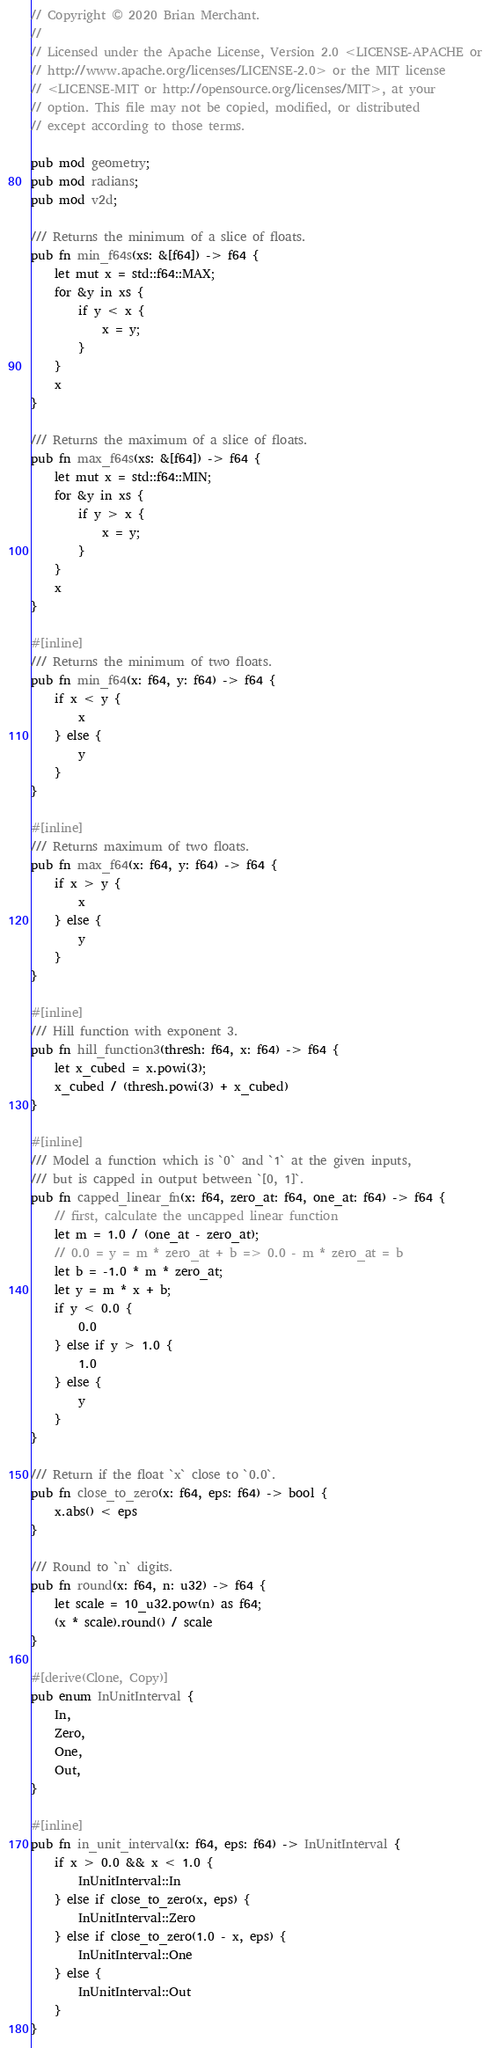Convert code to text. <code><loc_0><loc_0><loc_500><loc_500><_Rust_>// Copyright © 2020 Brian Merchant.
//
// Licensed under the Apache License, Version 2.0 <LICENSE-APACHE or
// http://www.apache.org/licenses/LICENSE-2.0> or the MIT license
// <LICENSE-MIT or http://opensource.org/licenses/MIT>, at your
// option. This file may not be copied, modified, or distributed
// except according to those terms.

pub mod geometry;
pub mod radians;
pub mod v2d;

/// Returns the minimum of a slice of floats.
pub fn min_f64s(xs: &[f64]) -> f64 {
    let mut x = std::f64::MAX;
    for &y in xs {
        if y < x {
            x = y;
        }
    }
    x
}

/// Returns the maximum of a slice of floats.
pub fn max_f64s(xs: &[f64]) -> f64 {
    let mut x = std::f64::MIN;
    for &y in xs {
        if y > x {
            x = y;
        }
    }
    x
}

#[inline]
/// Returns the minimum of two floats.
pub fn min_f64(x: f64, y: f64) -> f64 {
    if x < y {
        x
    } else {
        y
    }
}

#[inline]
/// Returns maximum of two floats.
pub fn max_f64(x: f64, y: f64) -> f64 {
    if x > y {
        x
    } else {
        y
    }
}

#[inline]
/// Hill function with exponent 3.
pub fn hill_function3(thresh: f64, x: f64) -> f64 {
    let x_cubed = x.powi(3);
    x_cubed / (thresh.powi(3) + x_cubed)
}

#[inline]
/// Model a function which is `0` and `1` at the given inputs,
/// but is capped in output between `[0, 1]`.
pub fn capped_linear_fn(x: f64, zero_at: f64, one_at: f64) -> f64 {
    // first, calculate the uncapped linear function
    let m = 1.0 / (one_at - zero_at);
    // 0.0 = y = m * zero_at + b => 0.0 - m * zero_at = b
    let b = -1.0 * m * zero_at;
    let y = m * x + b;
    if y < 0.0 {
        0.0
    } else if y > 1.0 {
        1.0
    } else {
        y
    }
}

/// Return if the float `x` close to `0.0`.
pub fn close_to_zero(x: f64, eps: f64) -> bool {
    x.abs() < eps
}

/// Round to `n` digits.
pub fn round(x: f64, n: u32) -> f64 {
    let scale = 10_u32.pow(n) as f64;
    (x * scale).round() / scale
}

#[derive(Clone, Copy)]
pub enum InUnitInterval {
    In,
    Zero,
    One,
    Out,
}

#[inline]
pub fn in_unit_interval(x: f64, eps: f64) -> InUnitInterval {
    if x > 0.0 && x < 1.0 {
        InUnitInterval::In
    } else if close_to_zero(x, eps) {
        InUnitInterval::Zero
    } else if close_to_zero(1.0 - x, eps) {
        InUnitInterval::One
    } else {
        InUnitInterval::Out
    }
}
</code> 